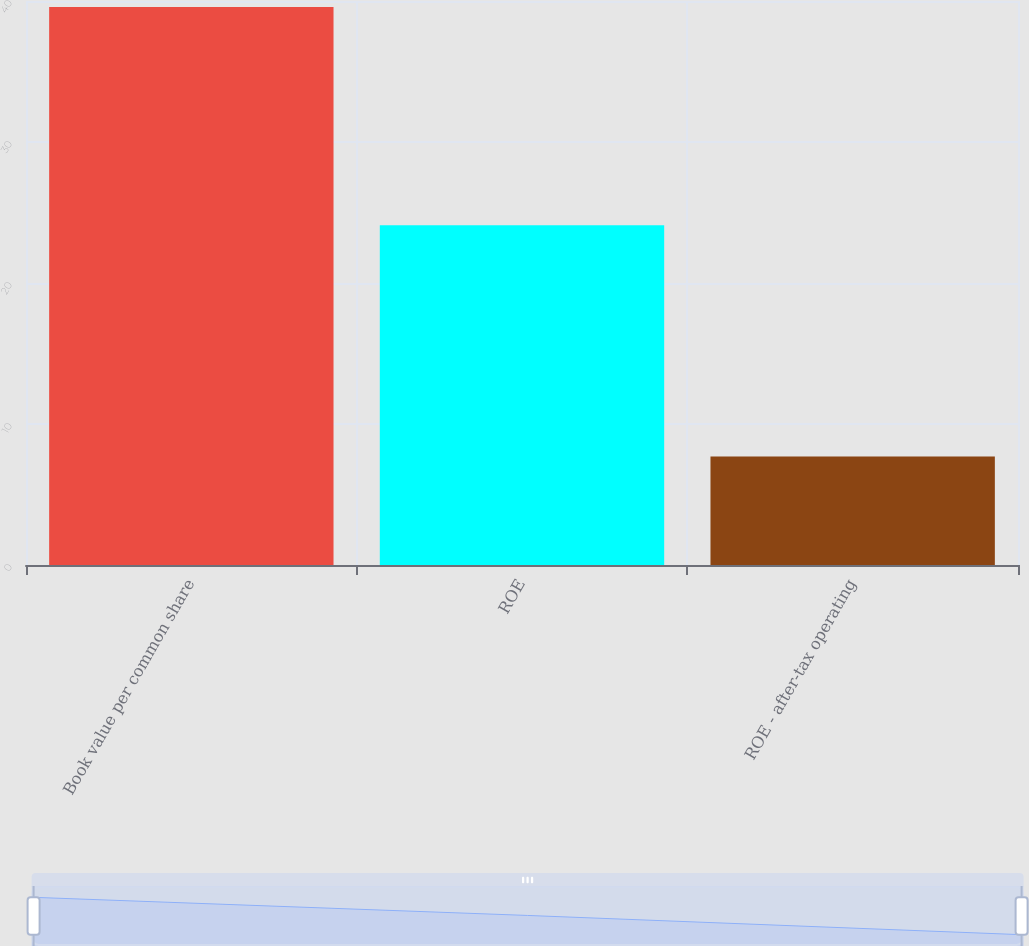Convert chart to OTSL. <chart><loc_0><loc_0><loc_500><loc_500><bar_chart><fcel>Book value per common share<fcel>ROE<fcel>ROE - after-tax operating<nl><fcel>39.57<fcel>24.1<fcel>7.69<nl></chart> 